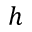<formula> <loc_0><loc_0><loc_500><loc_500>h</formula> 